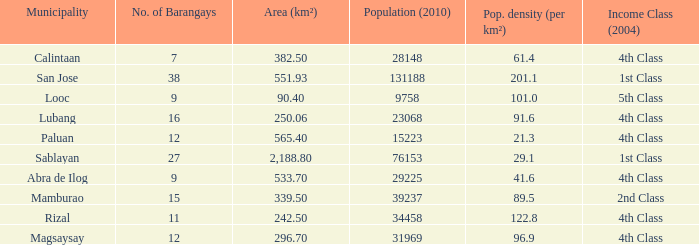What was the smallist population in 2010? 9758.0. 